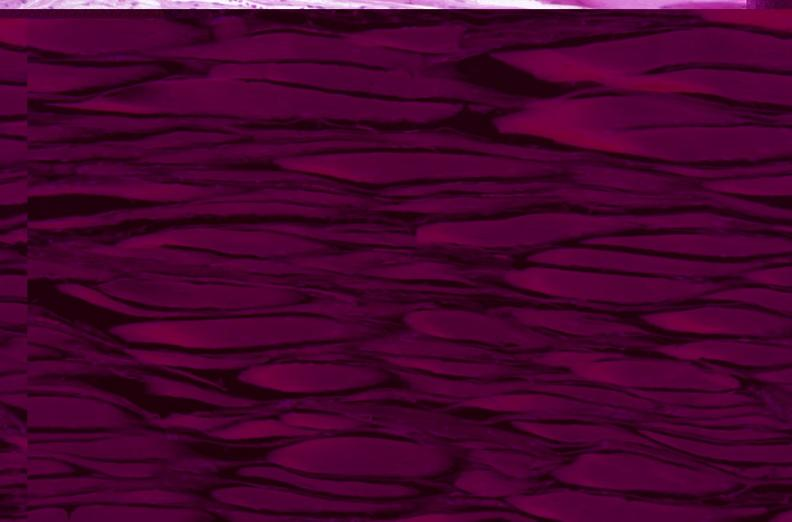does this protocol show skeletal muscle, atrophy due to immobilization cast?
Answer the question using a single word or phrase. No 